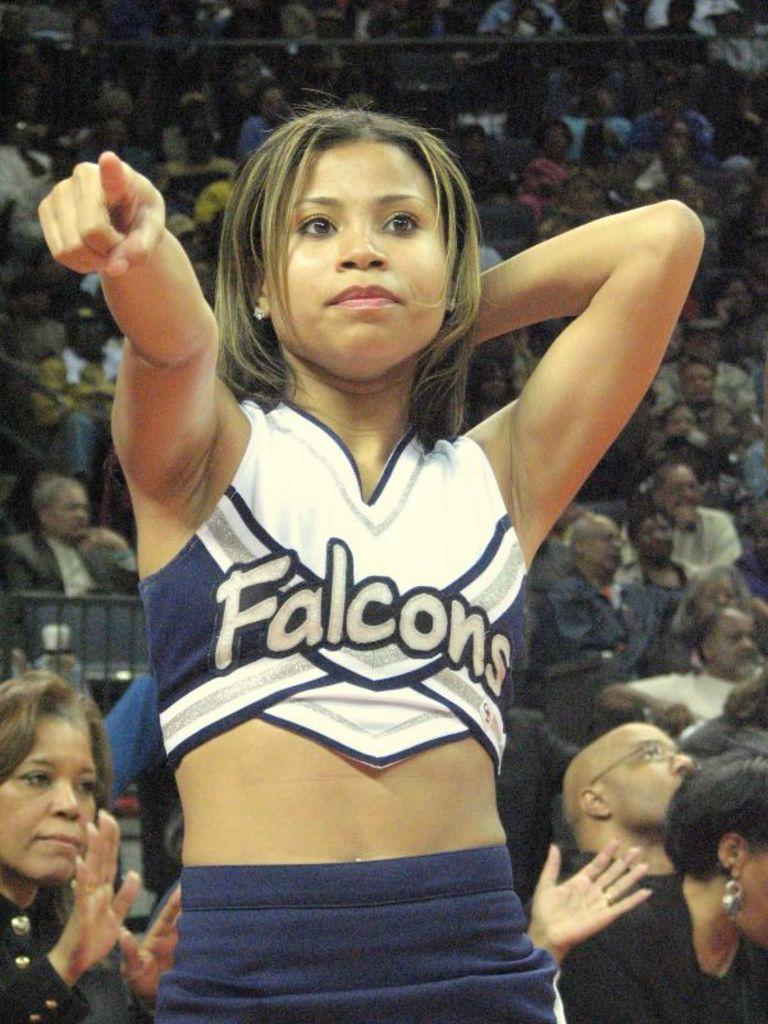<image>
Give a short and clear explanation of the subsequent image. a cheerleader that has the word falcons on it 